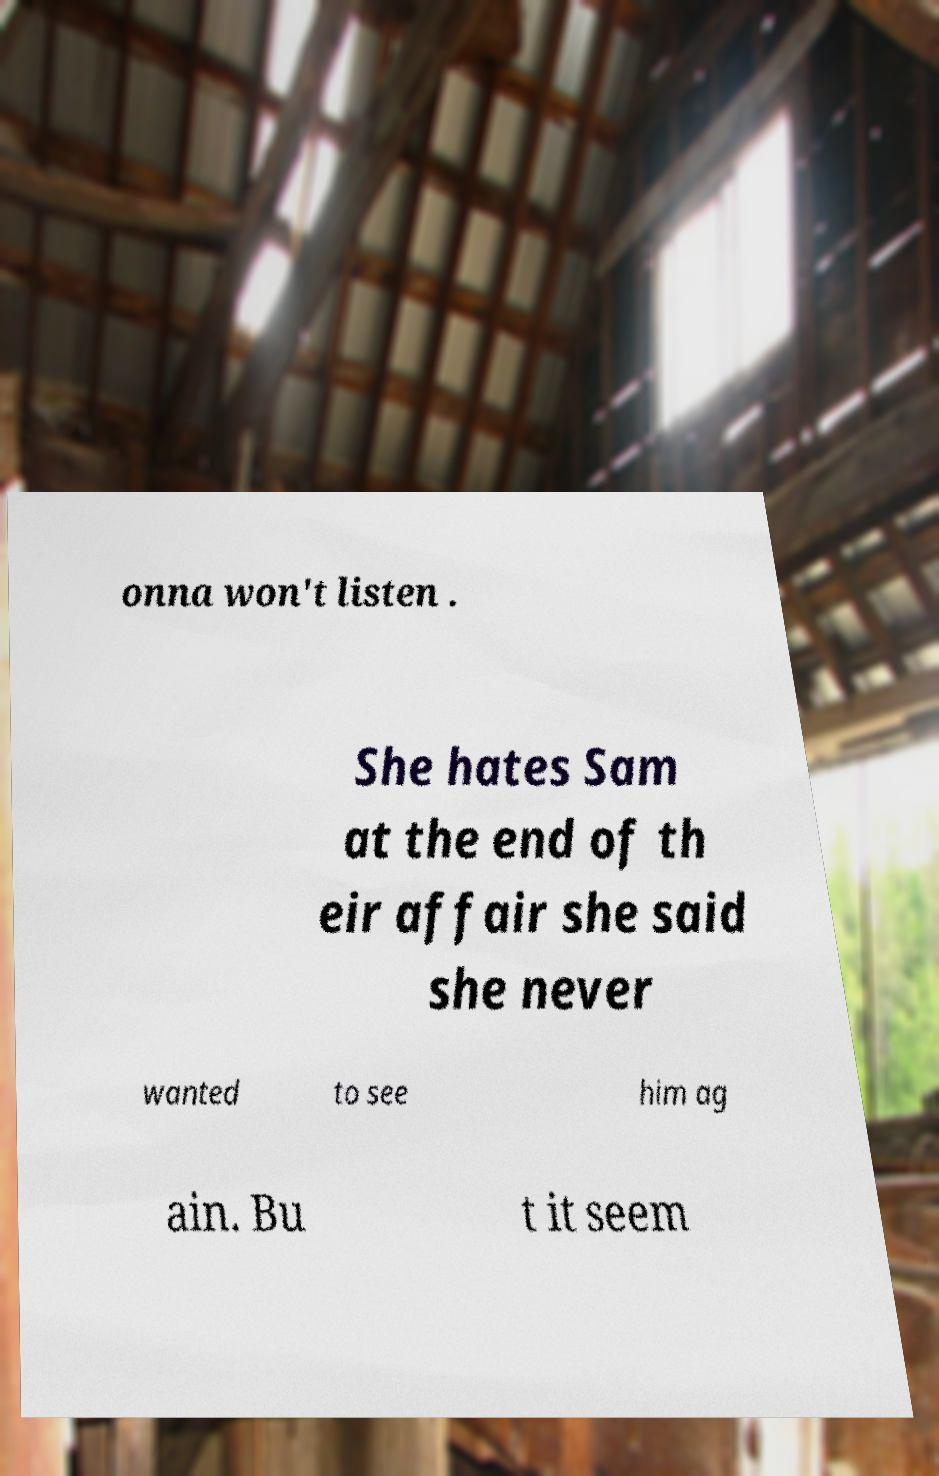I need the written content from this picture converted into text. Can you do that? onna won't listen . She hates Sam at the end of th eir affair she said she never wanted to see him ag ain. Bu t it seem 